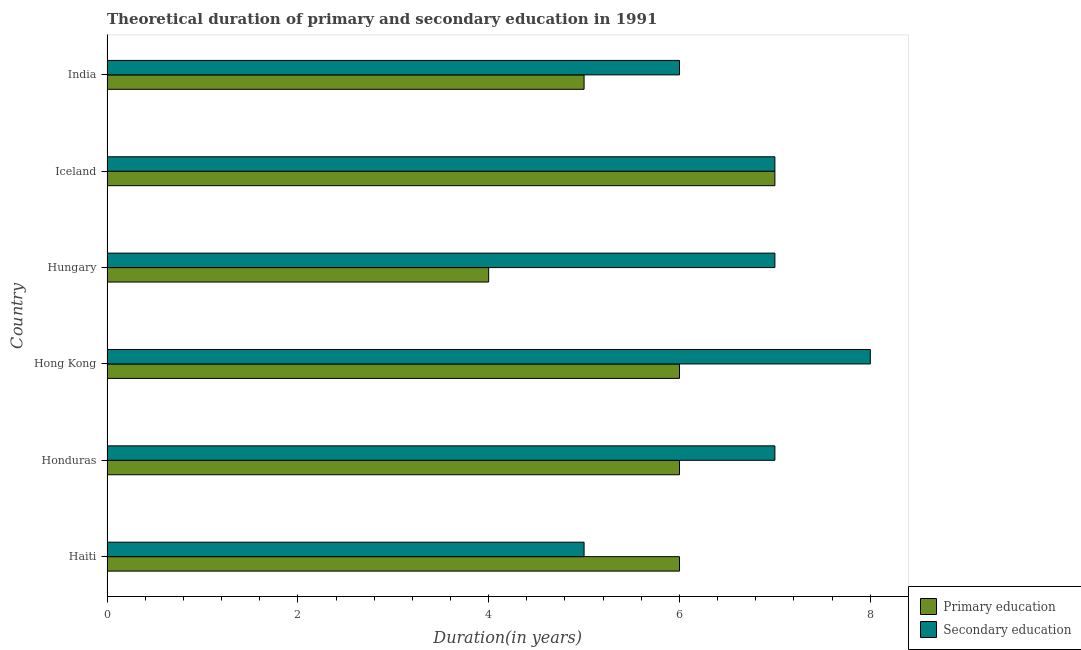Are the number of bars on each tick of the Y-axis equal?
Provide a succinct answer. Yes. What is the duration of secondary education in Hungary?
Give a very brief answer. 7. Across all countries, what is the maximum duration of primary education?
Keep it short and to the point. 7. Across all countries, what is the minimum duration of primary education?
Give a very brief answer. 4. In which country was the duration of secondary education maximum?
Give a very brief answer. Hong Kong. In which country was the duration of secondary education minimum?
Your answer should be very brief. Haiti. What is the total duration of primary education in the graph?
Offer a terse response. 34. What is the difference between the duration of secondary education in Honduras and that in Hungary?
Offer a terse response. 0. What is the difference between the duration of primary education in Hungary and the duration of secondary education in Haiti?
Offer a terse response. -1. What is the average duration of primary education per country?
Provide a short and direct response. 5.67. What is the difference between the duration of primary education and duration of secondary education in Hungary?
Offer a very short reply. -3. In how many countries, is the duration of primary education greater than 0.4 years?
Keep it short and to the point. 6. Is the difference between the duration of primary education in Honduras and India greater than the difference between the duration of secondary education in Honduras and India?
Offer a terse response. No. What is the difference between the highest and the lowest duration of secondary education?
Offer a terse response. 3. Is the sum of the duration of secondary education in Hungary and India greater than the maximum duration of primary education across all countries?
Give a very brief answer. Yes. How many bars are there?
Your answer should be compact. 12. Does the graph contain grids?
Your answer should be very brief. No. Where does the legend appear in the graph?
Keep it short and to the point. Bottom right. What is the title of the graph?
Your answer should be very brief. Theoretical duration of primary and secondary education in 1991. What is the label or title of the X-axis?
Offer a very short reply. Duration(in years). What is the label or title of the Y-axis?
Give a very brief answer. Country. What is the Duration(in years) of Primary education in Haiti?
Offer a terse response. 6. What is the Duration(in years) in Secondary education in Honduras?
Your response must be concise. 7. What is the Duration(in years) in Primary education in Hong Kong?
Make the answer very short. 6. What is the Duration(in years) of Secondary education in Hong Kong?
Your answer should be compact. 8. What is the Duration(in years) in Secondary education in Hungary?
Keep it short and to the point. 7. What is the Duration(in years) in Primary education in Iceland?
Ensure brevity in your answer.  7. What is the Duration(in years) of Secondary education in India?
Your answer should be compact. 6. Across all countries, what is the maximum Duration(in years) of Secondary education?
Make the answer very short. 8. What is the total Duration(in years) of Secondary education in the graph?
Provide a short and direct response. 40. What is the difference between the Duration(in years) in Primary education in Haiti and that in Hungary?
Make the answer very short. 2. What is the difference between the Duration(in years) of Secondary education in Haiti and that in Hungary?
Offer a very short reply. -2. What is the difference between the Duration(in years) of Primary education in Haiti and that in Iceland?
Keep it short and to the point. -1. What is the difference between the Duration(in years) of Primary education in Haiti and that in India?
Give a very brief answer. 1. What is the difference between the Duration(in years) in Secondary education in Haiti and that in India?
Give a very brief answer. -1. What is the difference between the Duration(in years) in Secondary education in Honduras and that in Hong Kong?
Your answer should be very brief. -1. What is the difference between the Duration(in years) in Secondary education in Honduras and that in Hungary?
Offer a very short reply. 0. What is the difference between the Duration(in years) of Primary education in Honduras and that in Iceland?
Give a very brief answer. -1. What is the difference between the Duration(in years) of Secondary education in Honduras and that in Iceland?
Offer a very short reply. 0. What is the difference between the Duration(in years) in Primary education in Honduras and that in India?
Keep it short and to the point. 1. What is the difference between the Duration(in years) of Primary education in Hong Kong and that in Hungary?
Make the answer very short. 2. What is the difference between the Duration(in years) in Secondary education in Hong Kong and that in Iceland?
Your response must be concise. 1. What is the difference between the Duration(in years) in Primary education in Hong Kong and that in India?
Provide a succinct answer. 1. What is the difference between the Duration(in years) in Secondary education in Hong Kong and that in India?
Keep it short and to the point. 2. What is the difference between the Duration(in years) in Primary education in Hungary and that in India?
Keep it short and to the point. -1. What is the difference between the Duration(in years) of Secondary education in Hungary and that in India?
Keep it short and to the point. 1. What is the difference between the Duration(in years) in Primary education in Haiti and the Duration(in years) in Secondary education in Hong Kong?
Your answer should be compact. -2. What is the difference between the Duration(in years) of Primary education in Haiti and the Duration(in years) of Secondary education in Iceland?
Give a very brief answer. -1. What is the difference between the Duration(in years) in Primary education in Haiti and the Duration(in years) in Secondary education in India?
Offer a terse response. 0. What is the difference between the Duration(in years) of Primary education in Honduras and the Duration(in years) of Secondary education in Hungary?
Keep it short and to the point. -1. What is the difference between the Duration(in years) of Primary education in Honduras and the Duration(in years) of Secondary education in Iceland?
Keep it short and to the point. -1. What is the difference between the Duration(in years) in Primary education in Hungary and the Duration(in years) in Secondary education in Iceland?
Your answer should be very brief. -3. What is the difference between the Duration(in years) in Primary education in Iceland and the Duration(in years) in Secondary education in India?
Your answer should be compact. 1. What is the average Duration(in years) in Primary education per country?
Provide a succinct answer. 5.67. What is the average Duration(in years) in Secondary education per country?
Make the answer very short. 6.67. What is the difference between the Duration(in years) in Primary education and Duration(in years) in Secondary education in Haiti?
Make the answer very short. 1. What is the difference between the Duration(in years) of Primary education and Duration(in years) of Secondary education in Honduras?
Provide a succinct answer. -1. What is the difference between the Duration(in years) of Primary education and Duration(in years) of Secondary education in Hong Kong?
Provide a short and direct response. -2. What is the difference between the Duration(in years) in Primary education and Duration(in years) in Secondary education in Hungary?
Provide a short and direct response. -3. What is the difference between the Duration(in years) of Primary education and Duration(in years) of Secondary education in India?
Give a very brief answer. -1. What is the ratio of the Duration(in years) of Secondary education in Haiti to that in Honduras?
Provide a short and direct response. 0.71. What is the ratio of the Duration(in years) of Primary education in Haiti to that in Iceland?
Offer a very short reply. 0.86. What is the ratio of the Duration(in years) in Secondary education in Haiti to that in Iceland?
Make the answer very short. 0.71. What is the ratio of the Duration(in years) of Secondary education in Haiti to that in India?
Make the answer very short. 0.83. What is the ratio of the Duration(in years) in Primary education in Honduras to that in Hungary?
Provide a short and direct response. 1.5. What is the ratio of the Duration(in years) of Primary education in Honduras to that in India?
Make the answer very short. 1.2. What is the ratio of the Duration(in years) in Secondary education in Hong Kong to that in Hungary?
Make the answer very short. 1.14. What is the ratio of the Duration(in years) in Primary education in Hong Kong to that in India?
Make the answer very short. 1.2. What is the ratio of the Duration(in years) in Primary education in Hungary to that in Iceland?
Your response must be concise. 0.57. What is the ratio of the Duration(in years) in Primary education in Iceland to that in India?
Give a very brief answer. 1.4. What is the ratio of the Duration(in years) in Secondary education in Iceland to that in India?
Offer a very short reply. 1.17. 